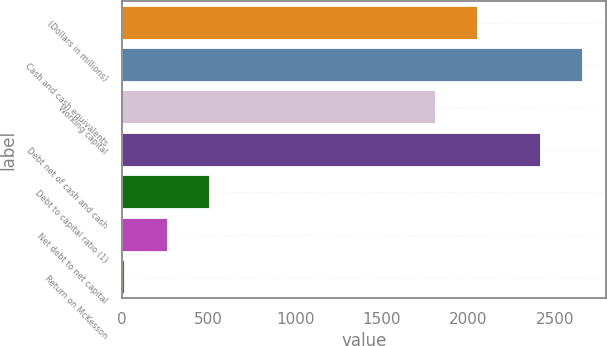Convert chart to OTSL. <chart><loc_0><loc_0><loc_500><loc_500><bar_chart><fcel>(Dollars in millions)<fcel>Cash and cash equivalents<fcel>Working capital<fcel>Debt net of cash and cash<fcel>Debt to capital ratio (1)<fcel>Net debt to net capital<fcel>Return on McKesson<nl><fcel>2056.77<fcel>2660.77<fcel>1813<fcel>2417<fcel>505.84<fcel>262.07<fcel>18.3<nl></chart> 